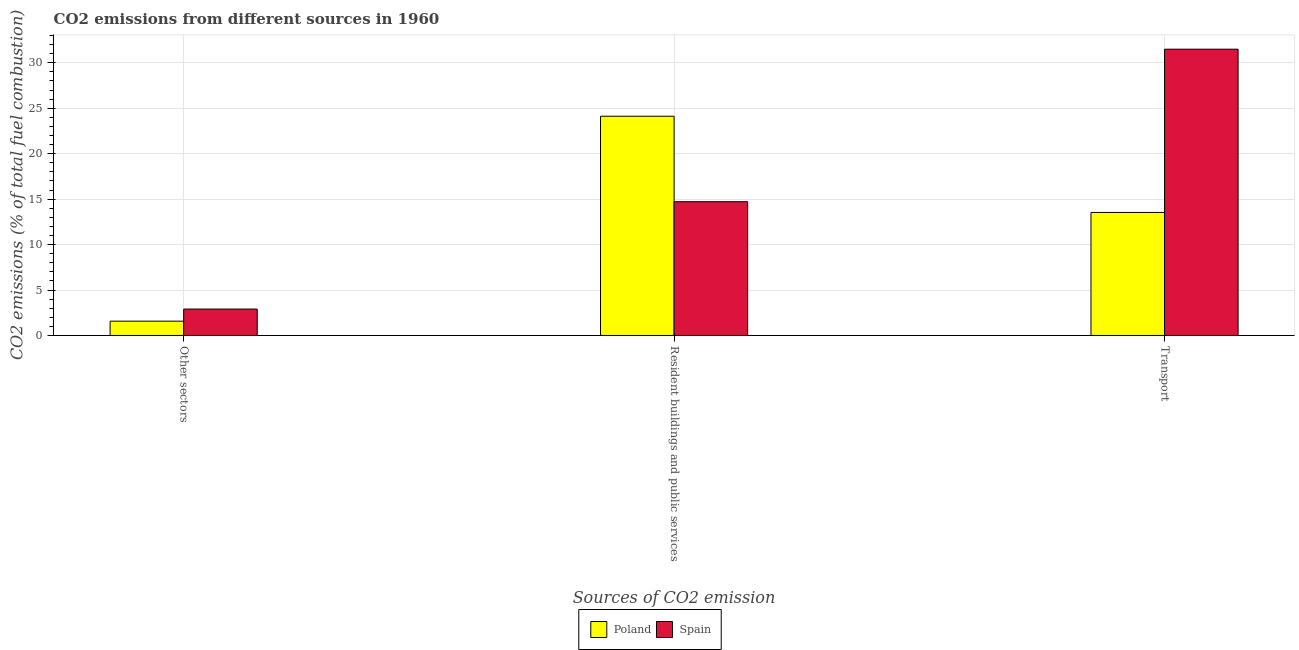What is the label of the 1st group of bars from the left?
Provide a short and direct response. Other sectors. What is the percentage of co2 emissions from resident buildings and public services in Spain?
Provide a succinct answer. 14.72. Across all countries, what is the maximum percentage of co2 emissions from transport?
Your answer should be compact. 31.5. Across all countries, what is the minimum percentage of co2 emissions from other sectors?
Your response must be concise. 1.57. In which country was the percentage of co2 emissions from resident buildings and public services minimum?
Keep it short and to the point. Spain. What is the total percentage of co2 emissions from other sectors in the graph?
Offer a terse response. 4.48. What is the difference between the percentage of co2 emissions from resident buildings and public services in Spain and that in Poland?
Provide a succinct answer. -9.41. What is the difference between the percentage of co2 emissions from other sectors in Spain and the percentage of co2 emissions from resident buildings and public services in Poland?
Your response must be concise. -21.22. What is the average percentage of co2 emissions from other sectors per country?
Make the answer very short. 2.24. What is the difference between the percentage of co2 emissions from transport and percentage of co2 emissions from other sectors in Spain?
Provide a succinct answer. 28.59. In how many countries, is the percentage of co2 emissions from other sectors greater than 2 %?
Keep it short and to the point. 1. What is the ratio of the percentage of co2 emissions from resident buildings and public services in Poland to that in Spain?
Keep it short and to the point. 1.64. Is the percentage of co2 emissions from other sectors in Poland less than that in Spain?
Provide a succinct answer. Yes. What is the difference between the highest and the second highest percentage of co2 emissions from resident buildings and public services?
Your response must be concise. 9.41. What is the difference between the highest and the lowest percentage of co2 emissions from transport?
Make the answer very short. 17.96. How many bars are there?
Your response must be concise. 6. How many countries are there in the graph?
Your response must be concise. 2. What is the difference between two consecutive major ticks on the Y-axis?
Make the answer very short. 5. Are the values on the major ticks of Y-axis written in scientific E-notation?
Offer a terse response. No. Does the graph contain any zero values?
Offer a terse response. No. Where does the legend appear in the graph?
Keep it short and to the point. Bottom center. How many legend labels are there?
Ensure brevity in your answer.  2. How are the legend labels stacked?
Make the answer very short. Horizontal. What is the title of the graph?
Your answer should be very brief. CO2 emissions from different sources in 1960. What is the label or title of the X-axis?
Make the answer very short. Sources of CO2 emission. What is the label or title of the Y-axis?
Your answer should be compact. CO2 emissions (% of total fuel combustion). What is the CO2 emissions (% of total fuel combustion) of Poland in Other sectors?
Offer a terse response. 1.57. What is the CO2 emissions (% of total fuel combustion) in Spain in Other sectors?
Provide a short and direct response. 2.91. What is the CO2 emissions (% of total fuel combustion) in Poland in Resident buildings and public services?
Make the answer very short. 24.12. What is the CO2 emissions (% of total fuel combustion) in Spain in Resident buildings and public services?
Offer a terse response. 14.72. What is the CO2 emissions (% of total fuel combustion) in Poland in Transport?
Provide a succinct answer. 13.54. What is the CO2 emissions (% of total fuel combustion) of Spain in Transport?
Ensure brevity in your answer.  31.5. Across all Sources of CO2 emission, what is the maximum CO2 emissions (% of total fuel combustion) in Poland?
Your answer should be very brief. 24.12. Across all Sources of CO2 emission, what is the maximum CO2 emissions (% of total fuel combustion) in Spain?
Ensure brevity in your answer.  31.5. Across all Sources of CO2 emission, what is the minimum CO2 emissions (% of total fuel combustion) of Poland?
Keep it short and to the point. 1.57. Across all Sources of CO2 emission, what is the minimum CO2 emissions (% of total fuel combustion) in Spain?
Offer a terse response. 2.91. What is the total CO2 emissions (% of total fuel combustion) in Poland in the graph?
Offer a very short reply. 39.23. What is the total CO2 emissions (% of total fuel combustion) in Spain in the graph?
Provide a succinct answer. 49.12. What is the difference between the CO2 emissions (% of total fuel combustion) in Poland in Other sectors and that in Resident buildings and public services?
Provide a short and direct response. -22.55. What is the difference between the CO2 emissions (% of total fuel combustion) of Spain in Other sectors and that in Resident buildings and public services?
Keep it short and to the point. -11.81. What is the difference between the CO2 emissions (% of total fuel combustion) in Poland in Other sectors and that in Transport?
Your answer should be compact. -11.96. What is the difference between the CO2 emissions (% of total fuel combustion) of Spain in Other sectors and that in Transport?
Keep it short and to the point. -28.59. What is the difference between the CO2 emissions (% of total fuel combustion) of Poland in Resident buildings and public services and that in Transport?
Your answer should be compact. 10.58. What is the difference between the CO2 emissions (% of total fuel combustion) of Spain in Resident buildings and public services and that in Transport?
Your answer should be very brief. -16.78. What is the difference between the CO2 emissions (% of total fuel combustion) of Poland in Other sectors and the CO2 emissions (% of total fuel combustion) of Spain in Resident buildings and public services?
Provide a short and direct response. -13.14. What is the difference between the CO2 emissions (% of total fuel combustion) of Poland in Other sectors and the CO2 emissions (% of total fuel combustion) of Spain in Transport?
Your response must be concise. -29.92. What is the difference between the CO2 emissions (% of total fuel combustion) of Poland in Resident buildings and public services and the CO2 emissions (% of total fuel combustion) of Spain in Transport?
Your answer should be very brief. -7.38. What is the average CO2 emissions (% of total fuel combustion) in Poland per Sources of CO2 emission?
Your response must be concise. 13.08. What is the average CO2 emissions (% of total fuel combustion) of Spain per Sources of CO2 emission?
Give a very brief answer. 16.37. What is the difference between the CO2 emissions (% of total fuel combustion) of Poland and CO2 emissions (% of total fuel combustion) of Spain in Other sectors?
Ensure brevity in your answer.  -1.33. What is the difference between the CO2 emissions (% of total fuel combustion) of Poland and CO2 emissions (% of total fuel combustion) of Spain in Resident buildings and public services?
Provide a succinct answer. 9.41. What is the difference between the CO2 emissions (% of total fuel combustion) in Poland and CO2 emissions (% of total fuel combustion) in Spain in Transport?
Provide a short and direct response. -17.96. What is the ratio of the CO2 emissions (% of total fuel combustion) of Poland in Other sectors to that in Resident buildings and public services?
Provide a succinct answer. 0.07. What is the ratio of the CO2 emissions (% of total fuel combustion) of Spain in Other sectors to that in Resident buildings and public services?
Provide a succinct answer. 0.2. What is the ratio of the CO2 emissions (% of total fuel combustion) in Poland in Other sectors to that in Transport?
Ensure brevity in your answer.  0.12. What is the ratio of the CO2 emissions (% of total fuel combustion) in Spain in Other sectors to that in Transport?
Provide a short and direct response. 0.09. What is the ratio of the CO2 emissions (% of total fuel combustion) of Poland in Resident buildings and public services to that in Transport?
Your response must be concise. 1.78. What is the ratio of the CO2 emissions (% of total fuel combustion) of Spain in Resident buildings and public services to that in Transport?
Offer a terse response. 0.47. What is the difference between the highest and the second highest CO2 emissions (% of total fuel combustion) in Poland?
Provide a short and direct response. 10.58. What is the difference between the highest and the second highest CO2 emissions (% of total fuel combustion) of Spain?
Offer a very short reply. 16.78. What is the difference between the highest and the lowest CO2 emissions (% of total fuel combustion) of Poland?
Provide a short and direct response. 22.55. What is the difference between the highest and the lowest CO2 emissions (% of total fuel combustion) in Spain?
Give a very brief answer. 28.59. 